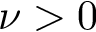<formula> <loc_0><loc_0><loc_500><loc_500>\nu > 0</formula> 